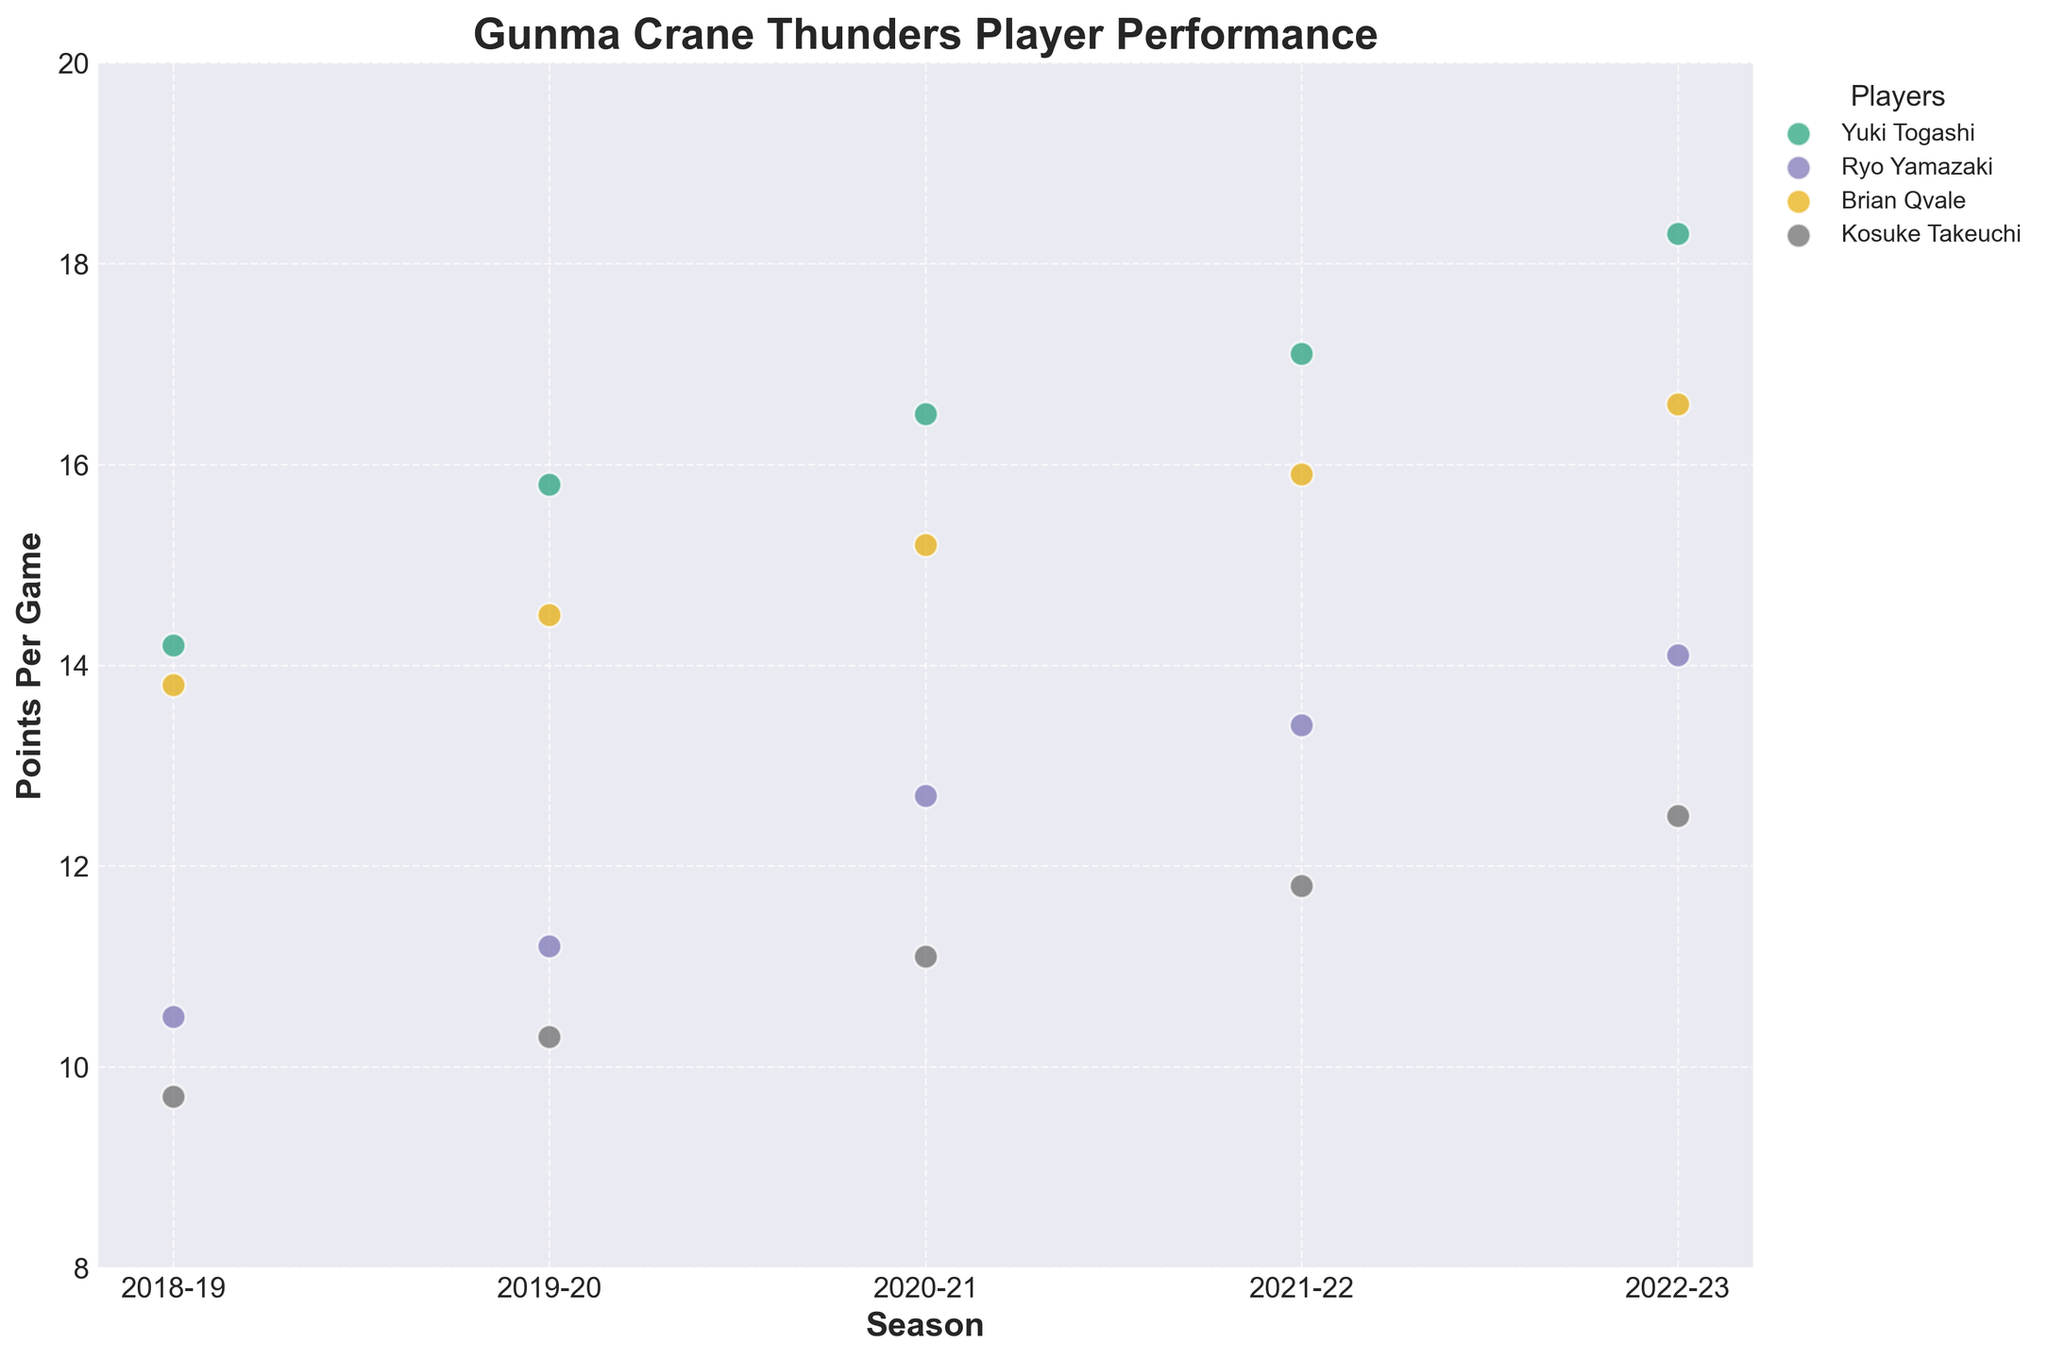How many players' performance statistics are displayed in the plot? There are different colors and labels in the legend for each player displayed in the scatter plot. By counting them, we can identify there are four distinct players.
Answer: 4 Who has the highest points per game in the 2022-23 season? Observing the scatter plot, the dot representing the 2022-23 season at the highest position on the vertical axis indicates the highest points per game. Yuki Togashi's data point is the highest.
Answer: Yuki Togashi What is the trend in points per game for Kosuke Takeuchi over the last five seasons? By following the points for Kosuke Takeuchi from 2018-19 to 2022-23, we see the values consistently increase each year, indicating an upward trend.
Answer: Increasing What's the difference in points per game between Yuki Togashi and Brian Qvale in the 2020-21 season? Yuki Togashi's points per game for 2020-21 is 16.5 and Brian Qvale's is 15.2. Subtracting Brian Qvale's points from Yuki Togashi's gives the difference: 16.5 - 15.2 = 1.3
Answer: 1.3 Which player's performance shows the most consistent improvement over the five years? Each player's points per game over the five years forms a trend. Checking the plot, Ryo Yamazaki's points show a consistent, steady increase without any decreases over the period.
Answer: Ryo Yamazaki What is the average points per game for Brian Qvale over the five seasons? Adding Brian Qvale's points per game for each season: 13.8 + 14.5 + 15.2 + 15.9 + 16.6 = 76, and then dividing by 5: 76 / 5 = 15.2
Answer: 15.2 What is the overall range of points per game for all players? The highest point represented is Yuki Togashi's 18.3 in the 2022-23 season, and the lowest is Kosuke Takeuchi's 9.7 in the 2018-19 season. The range is 18.3 - 9.7 = 8.6
Answer: 8.6 Which season shows the most significant increase for Yuki Togashi compared to the previous season? By comparing each year's increase for Yuki Togashi: (2019-20: 1.6), (2020-21: 0.7), (2021-22: 0.6), (2022-23: 1.2), the most significant increase occurs from the 2018-19 to 2019-20 season.
Answer: 2019-20 